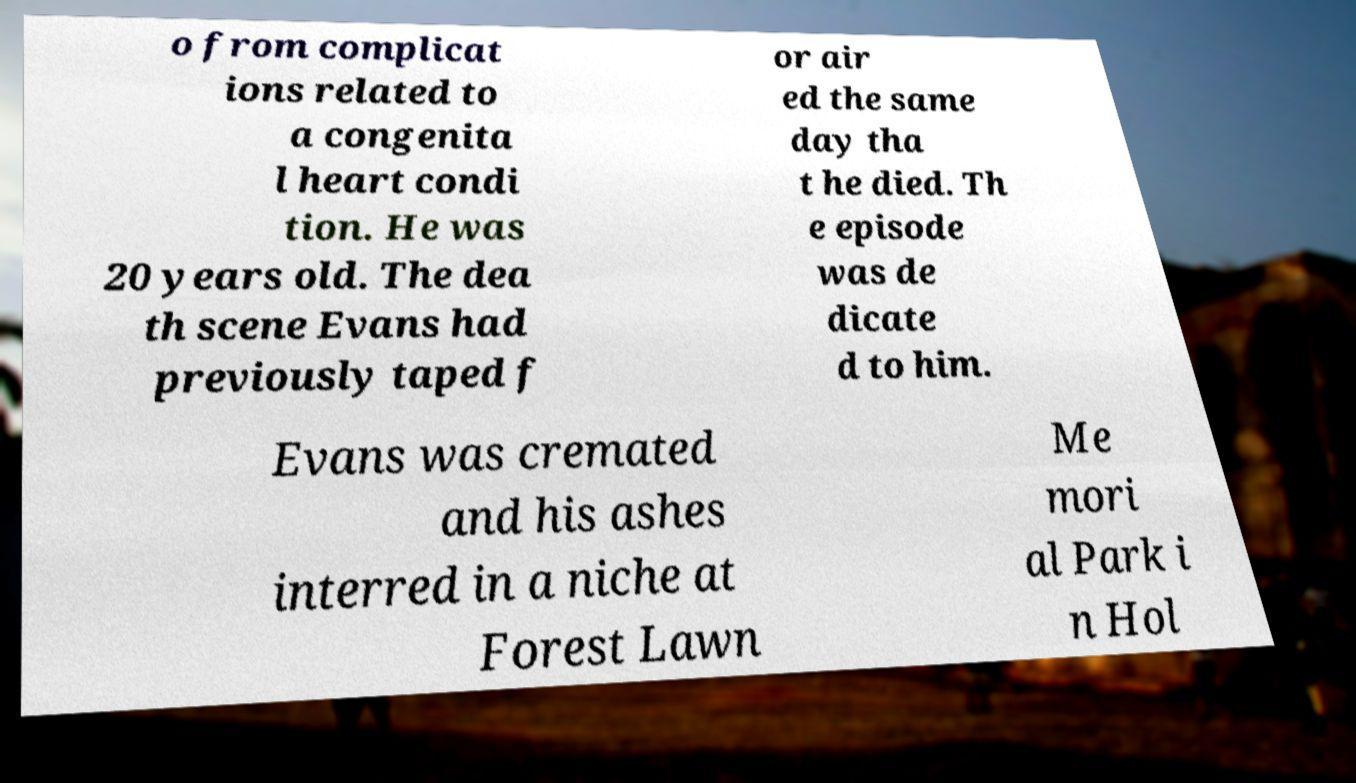Please identify and transcribe the text found in this image. o from complicat ions related to a congenita l heart condi tion. He was 20 years old. The dea th scene Evans had previously taped f or air ed the same day tha t he died. Th e episode was de dicate d to him. Evans was cremated and his ashes interred in a niche at Forest Lawn Me mori al Park i n Hol 